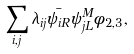Convert formula to latex. <formula><loc_0><loc_0><loc_500><loc_500>\sum _ { i , j } \lambda _ { i j } \bar { \psi _ { i R } } \psi ^ { M } _ { j L } \phi _ { 2 , 3 } ,</formula> 